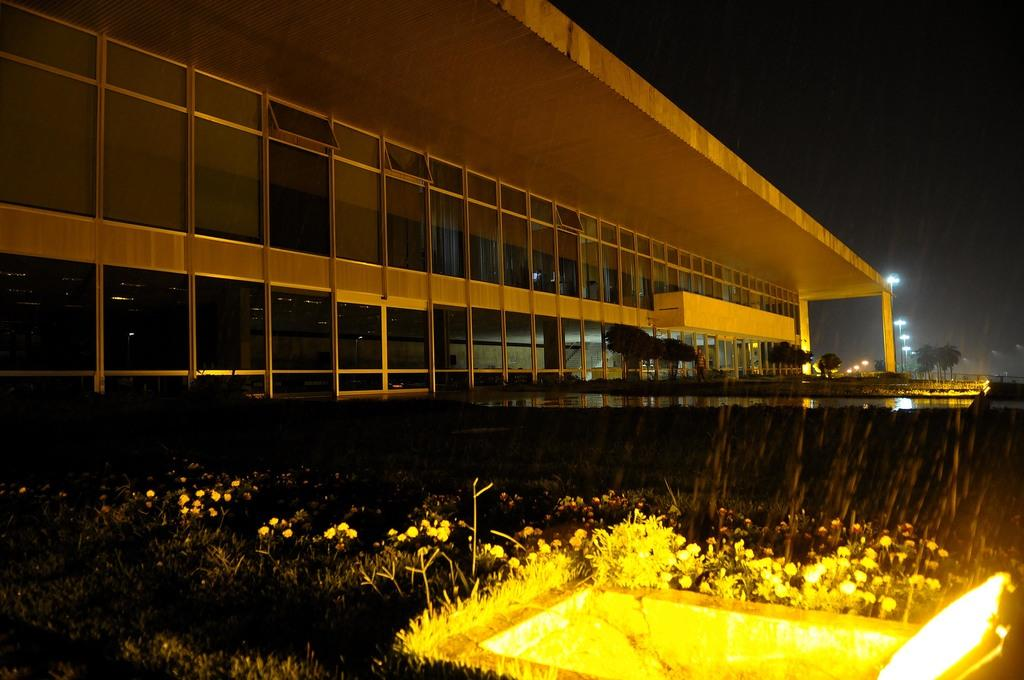What is the main structure in the image? There is a building in the image. What type of vegetation is present near the building? There are plants with flowers in front of the building and trees beside the building. What other objects can be seen in the image? There are lampposts in the image. Can you see a wren perched on the lamppost in the image? There is no wren present in the image. 